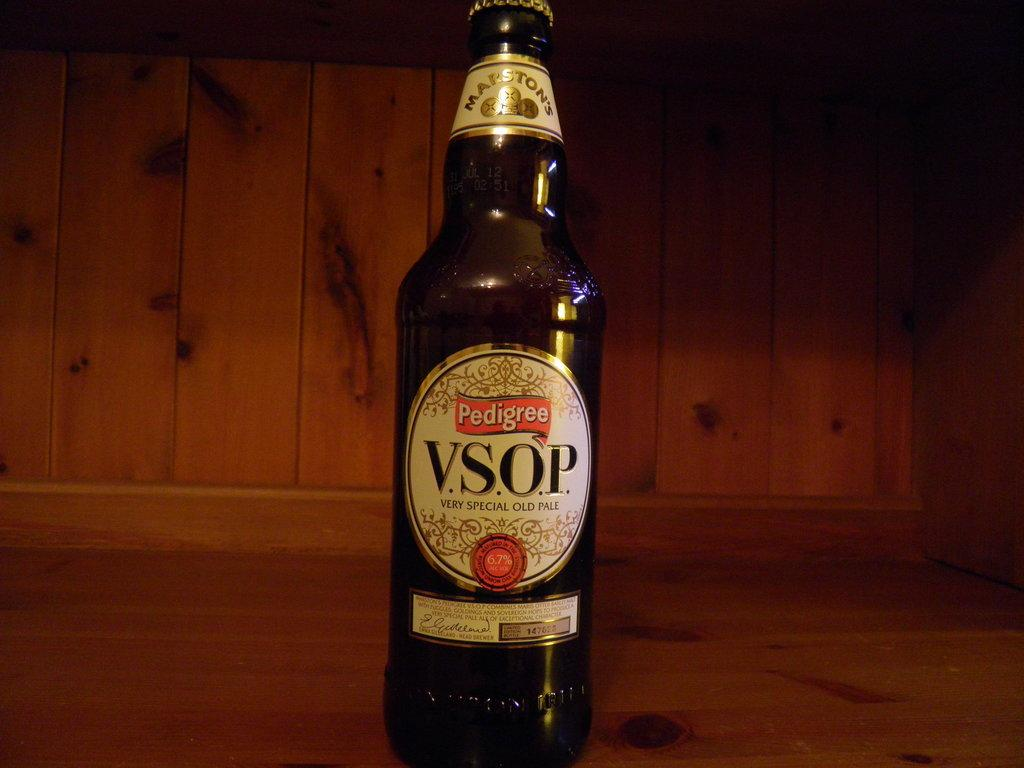Provide a one-sentence caption for the provided image. A bottle of Pedigree V.S.O.P. beer on a wooden shelf. 